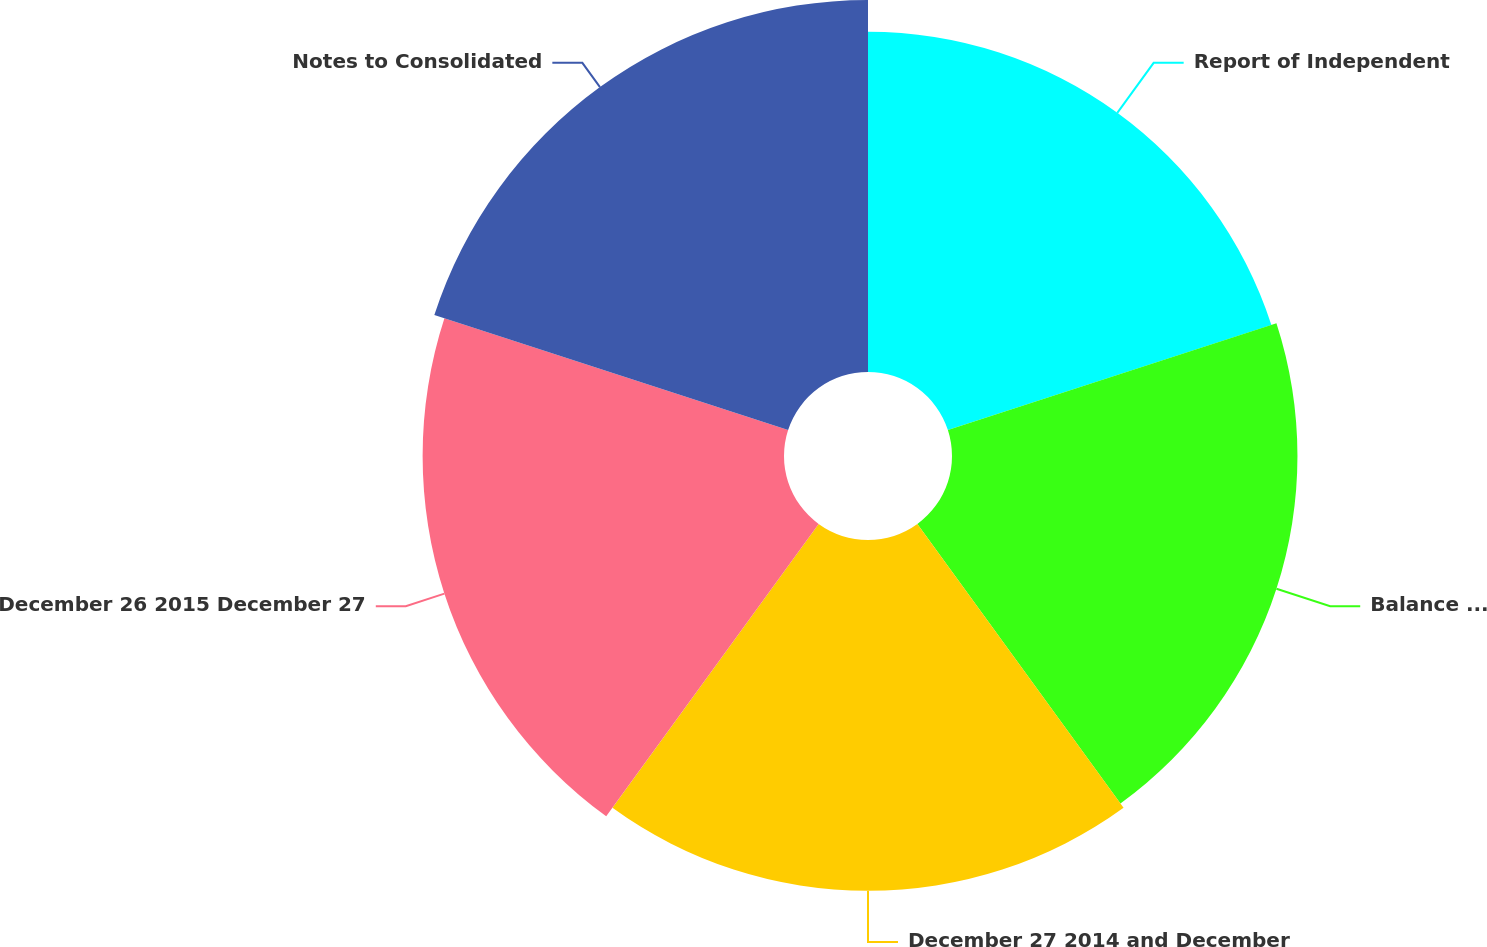Convert chart. <chart><loc_0><loc_0><loc_500><loc_500><pie_chart><fcel>Report of Independent<fcel>Balance Sheets as of December<fcel>December 27 2014 and December<fcel>December 26 2015 December 27<fcel>Notes to Consolidated<nl><fcel>19.22%<fcel>19.52%<fcel>19.82%<fcel>20.42%<fcel>21.02%<nl></chart> 